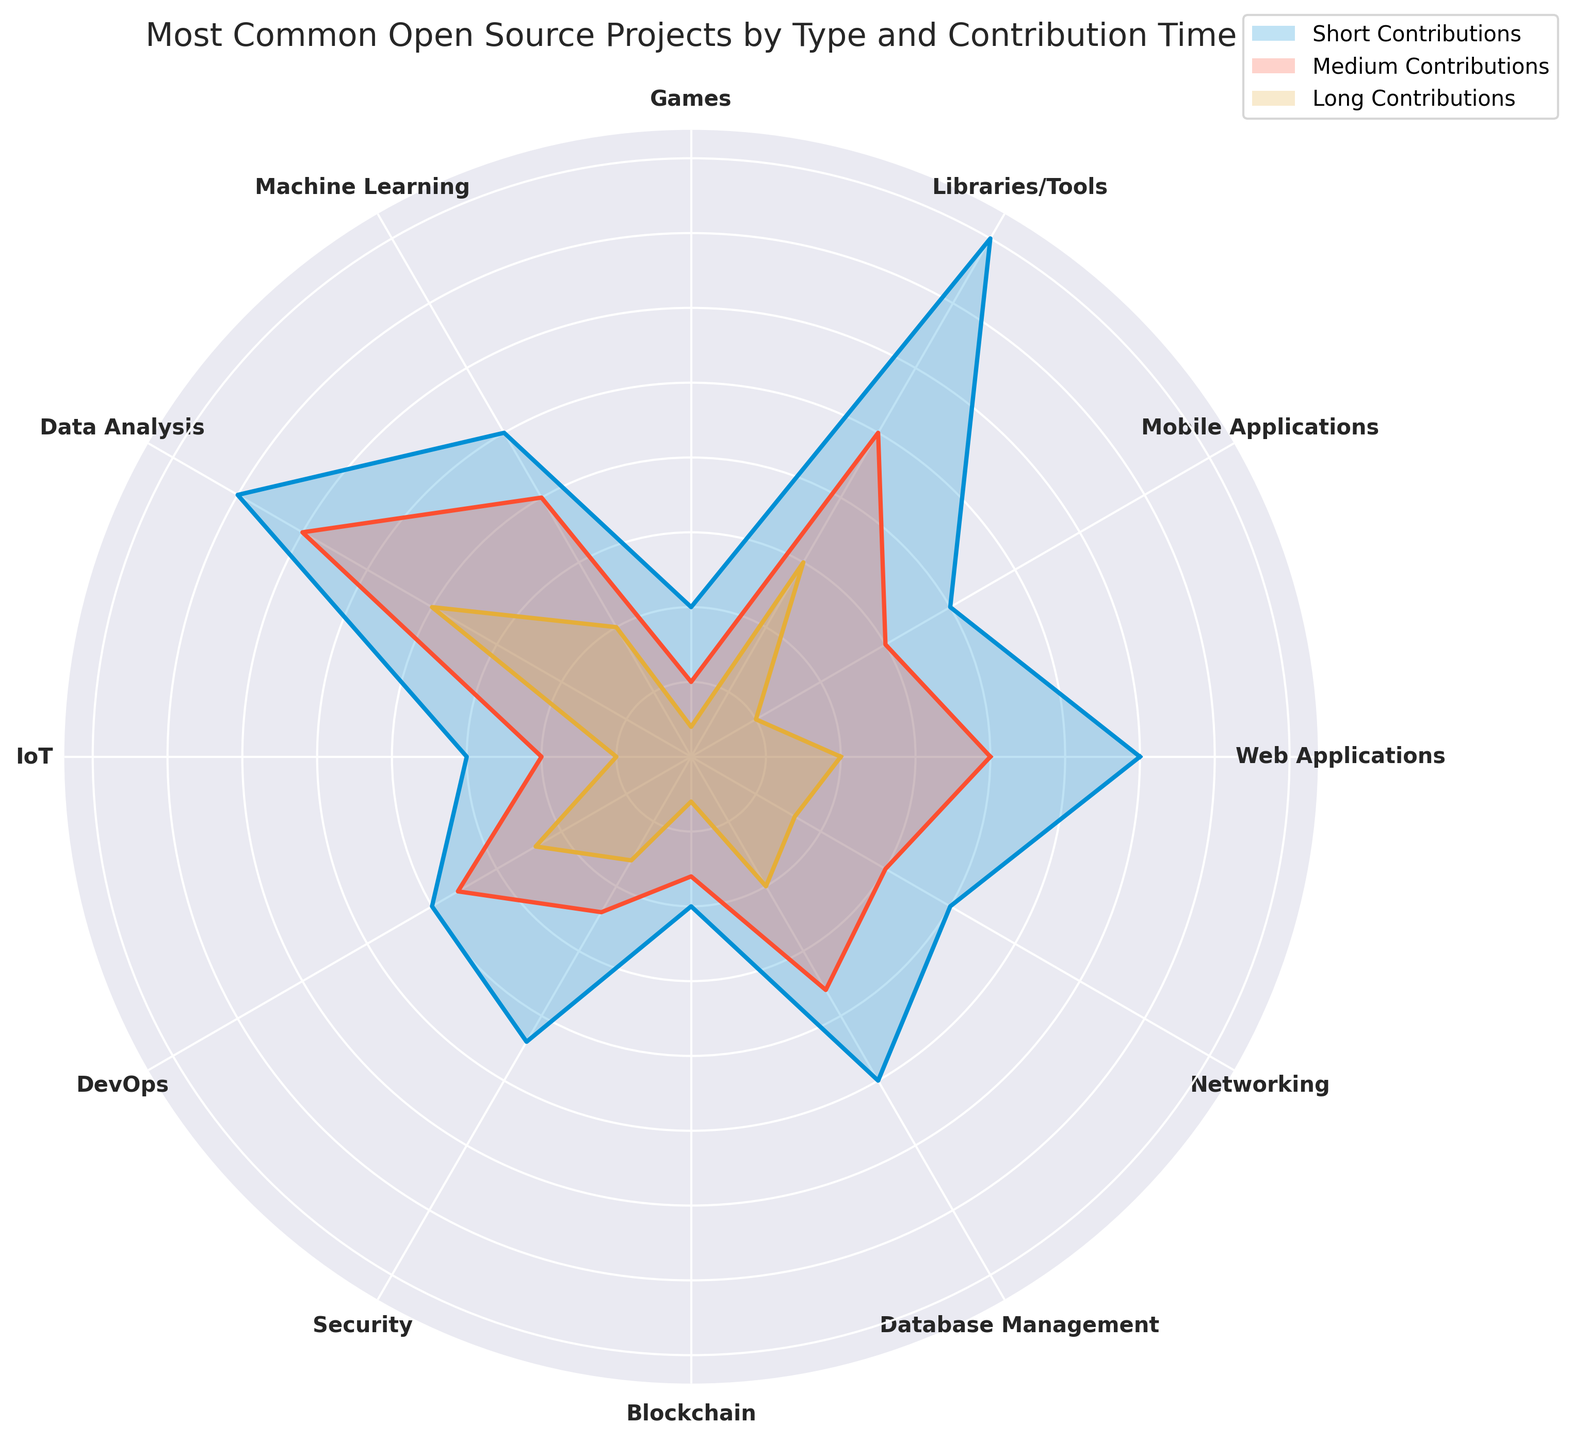Which project type has the highest number of short contributions? The "Libraries/Tools" category in the rose chart has the largest radial distance for short contributions, indicating it has the highest number of short contributions compared to the other project types.
Answer: Libraries/Tools Which project type has the least number of long contributions? The "Games" category in the rose chart has the smallest radial distance for long contributions, indicating it has the least number of long contributions compared to the other project types.
Answer: Games Between "Web Applications" and "Machine Learning," which has more medium contributions? By observing the radial distances for the medium contributions, "Data Analysis" has a longer radial distance than "Machine Learning," indicating more medium contributions.
Answer: Data Analysis What is the sum of long contributions for "Web Applications" and "Machine Learning"? The bar lengths for long contributions are 10 for "Web Applications" and 10 for "Machine Learning." Summing these values gives 10 + 10 = 20.
Answer: 20 Which project type has more total contributions (short + medium + long): "Security" or "Networking"? For "Security," the contributions are 22 (short) + 12 (medium) + 8 (long) = 42. For "Networking," the contributions are 20 (short) + 15 (medium) + 8 (long) = 43. "Networking" has more total contributions.
Answer: Networking What is the difference in short contributions between "Libraries/Tools" and "Mobile Applications"? The short contributions for "Libraries/Tools" are 40 and for "Mobile Applications" are 20. The difference is 40 - 20 = 20.
Answer: 20 What is the ratio of short to long contributions in the "Data Analysis" category? The short contributions in "Data Analysis" are 35 and the long contributions are 20. The ratio is 35:20, which simplifies to 7:4.
Answer: 7:4 Which project type has the second-highest number of medium contributions? Observing the radial lengths of medium contributions, "Data Analysis" has the highest and "Libraries/Tools" has the second longest for medium contributions.
Answer: Libraries/Tools What is the average number of long contributions across all project types? Sum the long contributions: 10 (Web) + 5 (Mobile) + 15 (Libraries) + 2 (Games) + 10 (ML) + 20 (Data Analysis) + 5 (IoT) + 12 (DevOps) + 8 (Security) + 3 (Blockchain) + 10 (Database) + 8 (Networking) = 108. Divide by the number of project types: 108 / 12 = 9.
Answer: 9 Which has more total contributions in the "DevOps" category, short plus medium or medium plus long? Short + Medium: 20 + 18 = 38, and Medium + Long: 18 + 12 = 30. Short plus medium has more contributions.
Answer: Short + Medium 